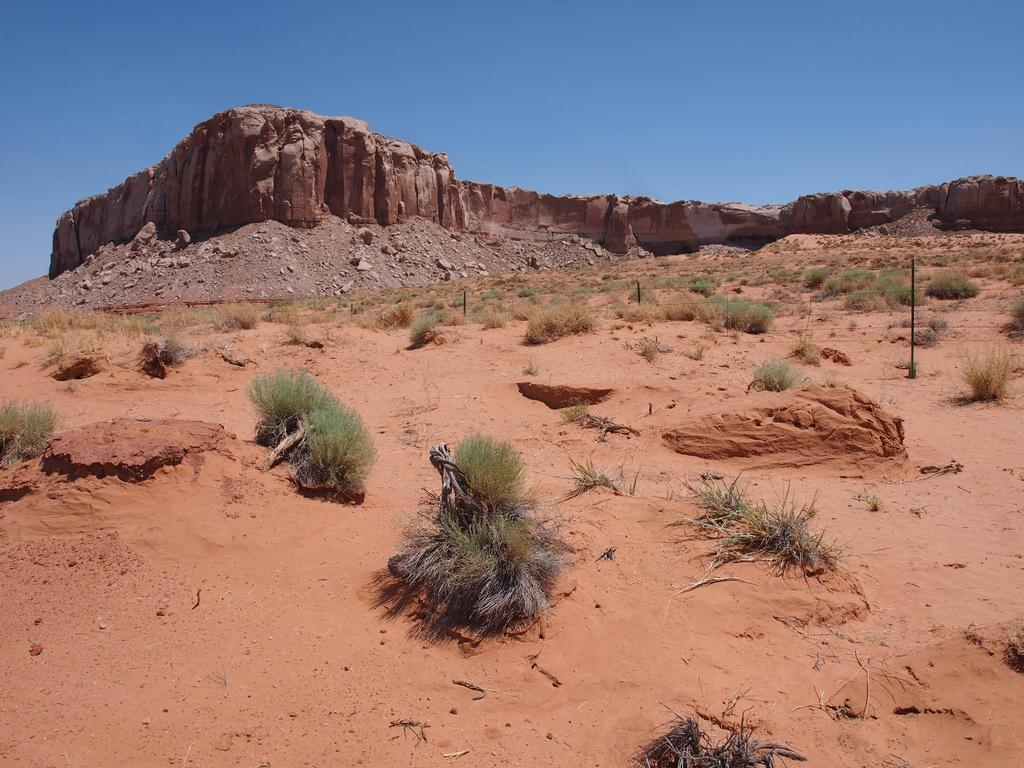What type of surface can be seen in the image? There is ground visible in the image. What type of vegetation is present in the image? There is grass in the image. What objects are made of metal in the image? There are rods in the image. What type of natural formation is present in the image? There is a rock in the image. What is visible in the distance in the image? The sky is visible in the background of the image. What type of soup is being served in the image? There is no soup present in the image. What news headline can be seen on the newspaper in the image? There is no newspaper or news headline present in the image. 